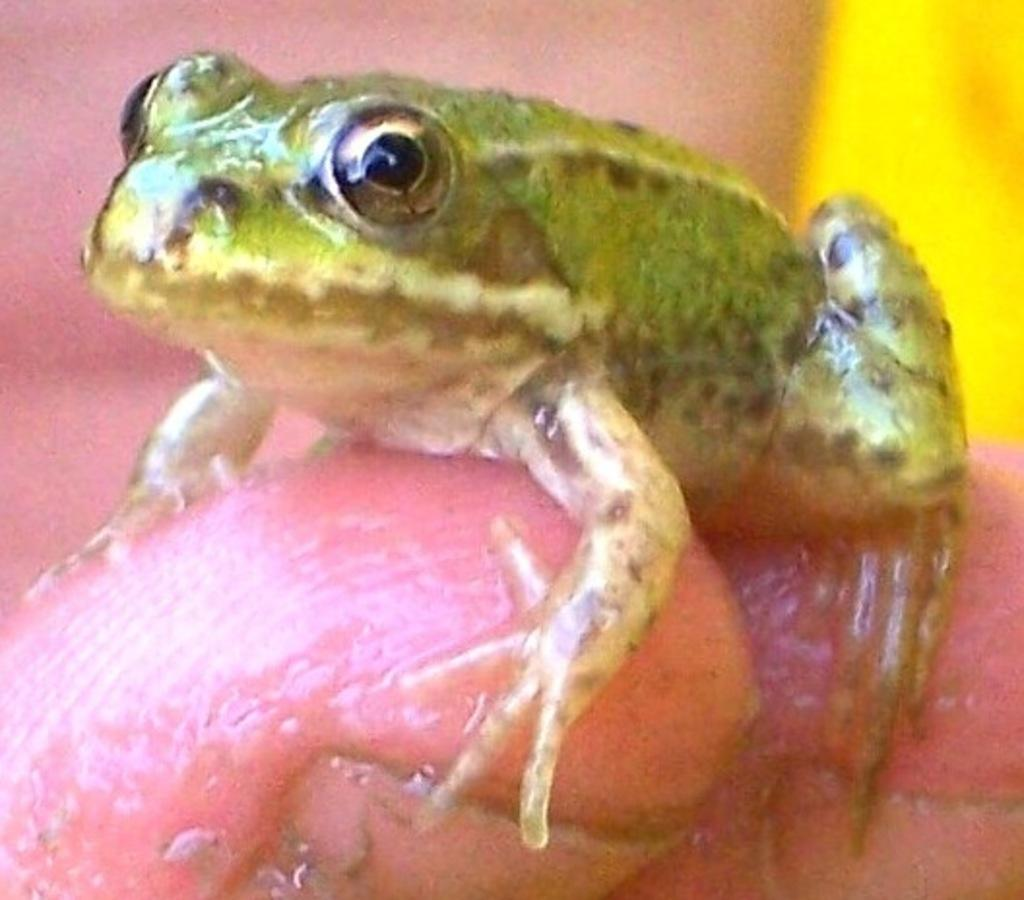What type of animal is present on a person's finger in the image? There is a frog present on a person's finger in the image. What type of straw can be seen being used to fly the kite in the image? There is no straw or kite present in the image; it only features a frog on a person's finger. 